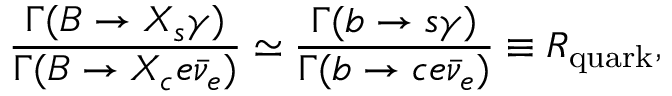Convert formula to latex. <formula><loc_0><loc_0><loc_500><loc_500>\frac { \Gamma ( B \to X _ { s } \gamma ) } { \Gamma ( B \to X _ { c } e \bar { \nu } _ { e } ) } \simeq \frac { \Gamma ( b \to s \gamma ) } { \Gamma ( b \to c e \bar { \nu } _ { e } ) } \equiv R _ { q u a r k } ,</formula> 